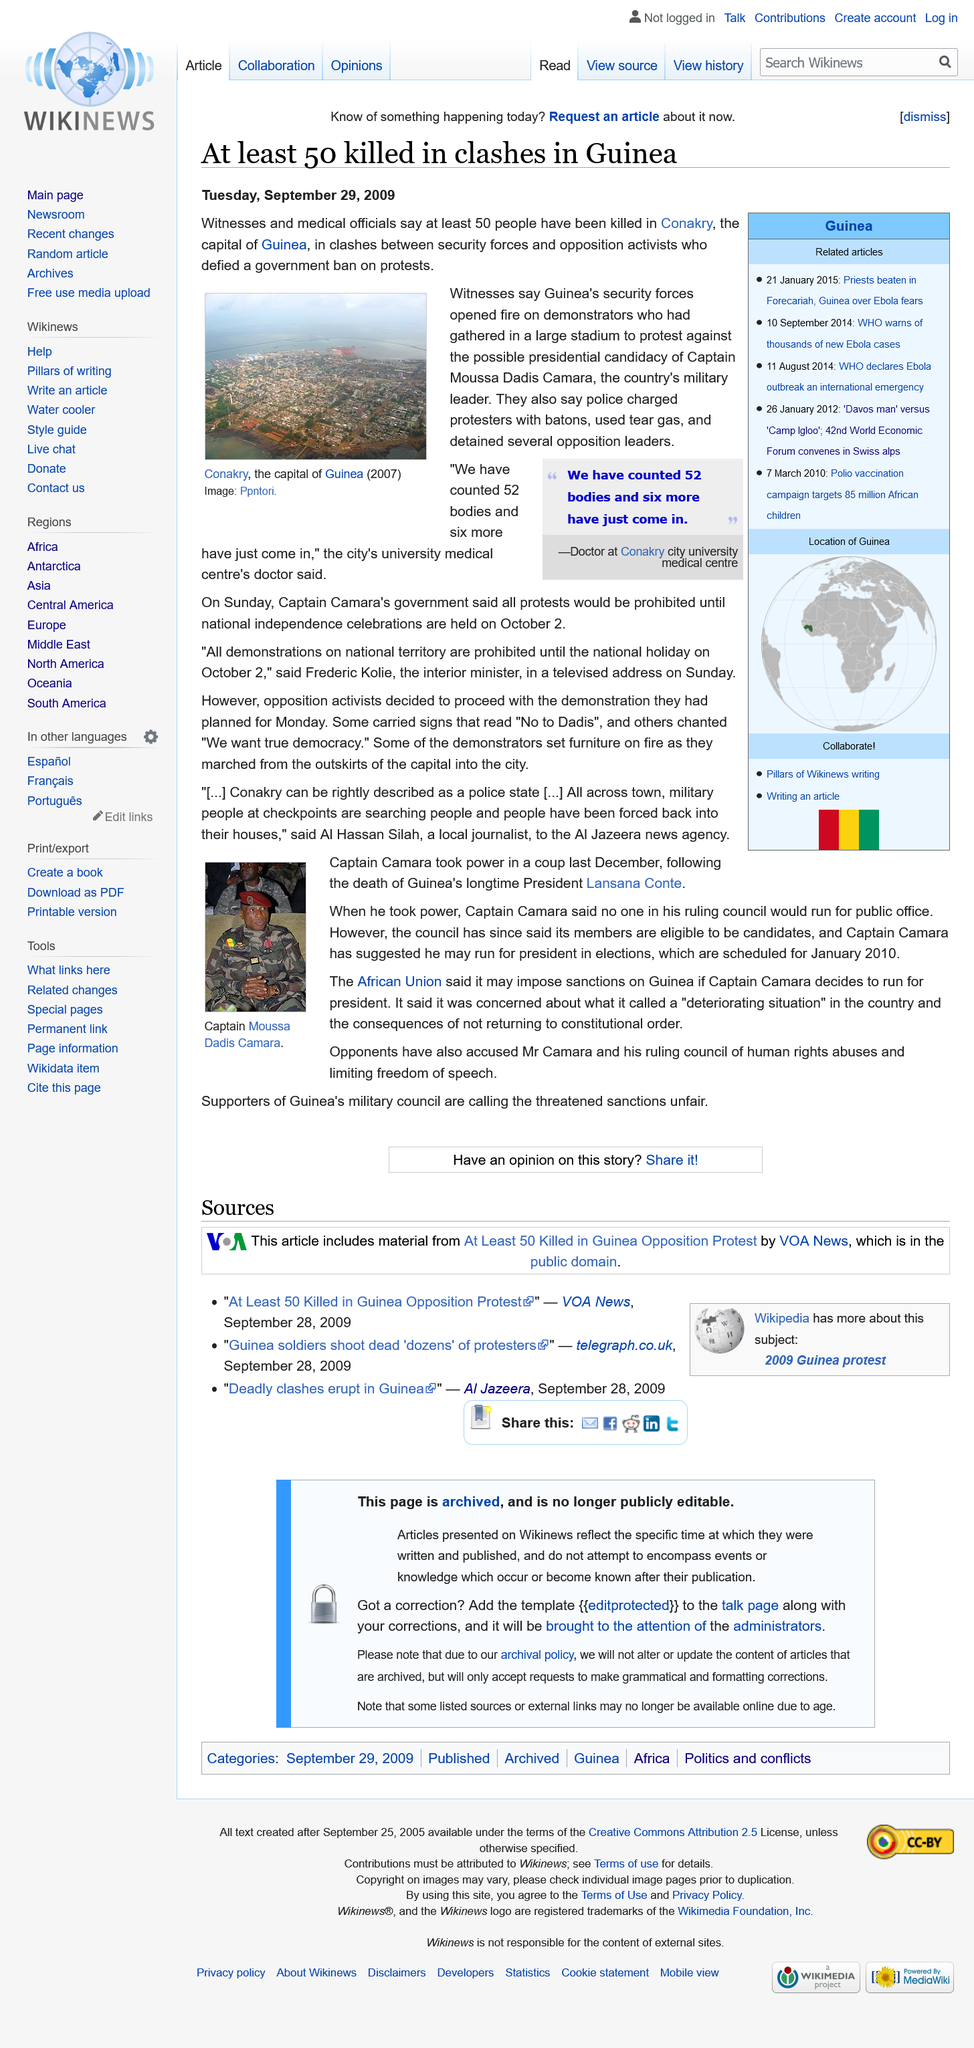Draw attention to some important aspects in this diagram. Guinea's security forces fired on demonstrators. The capital of Guinea is Conakry, as declared. The city's university medical center's doctor has counted 52 bodies and six additional bodies have just been brought in. 